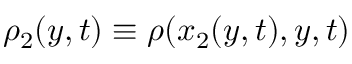<formula> <loc_0><loc_0><loc_500><loc_500>\rho _ { 2 } ( y , t ) \equiv \rho ( x _ { 2 } ( y , t ) , y , t )</formula> 